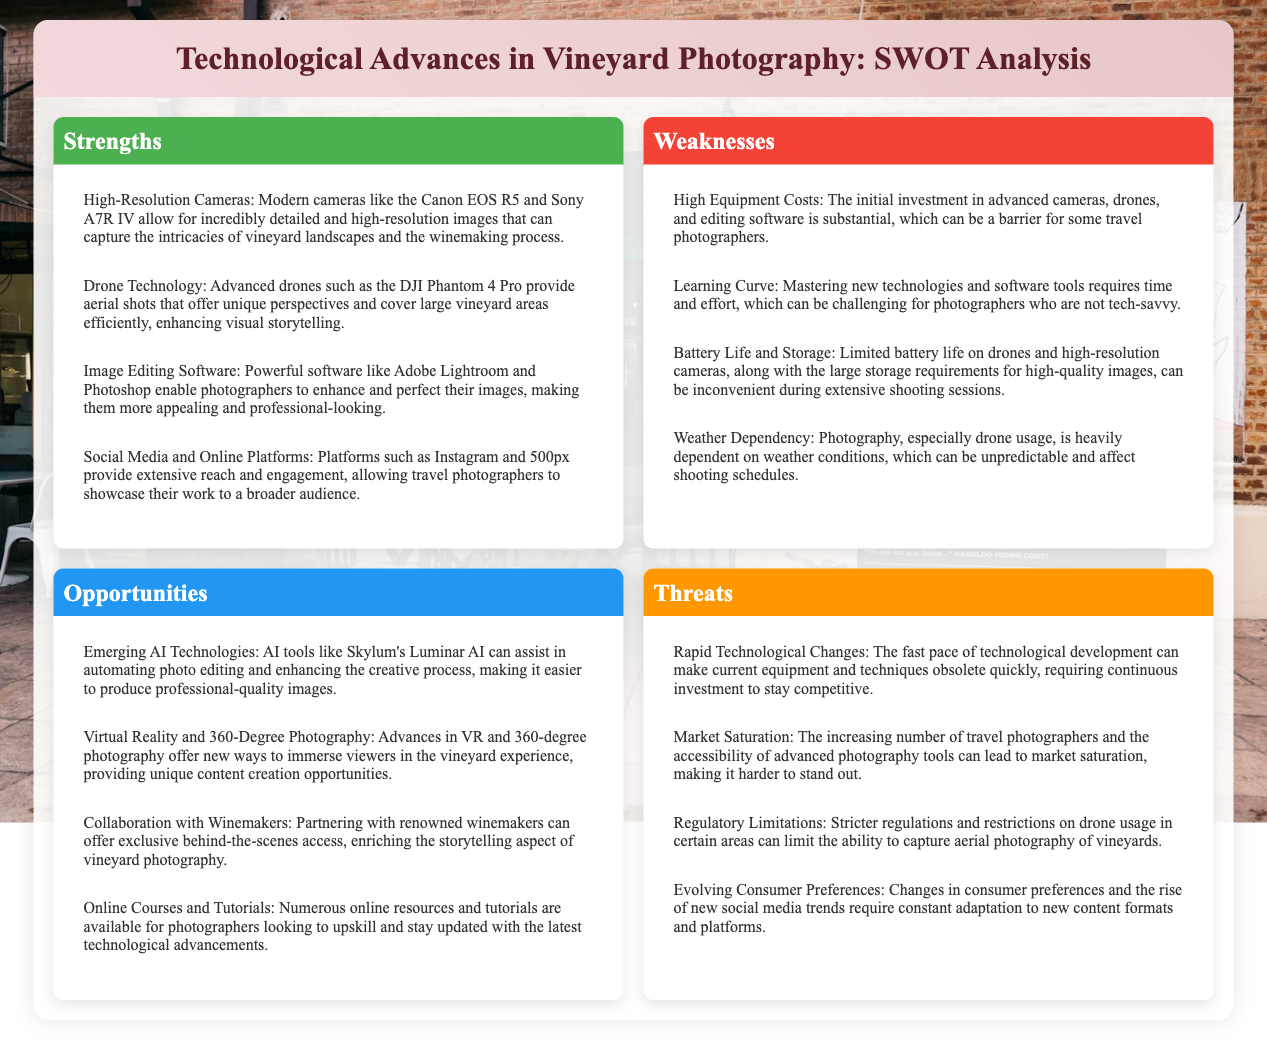What are two examples of high-resolution cameras? The document lists two examples of high-resolution cameras: Canon EOS R5 and Sony A7R IV.
Answer: Canon EOS R5 and Sony A7R IV What is the main challenge regarding drone usage in vineyard photography? The document states that weather dependency is a significant challenge affecting shooting schedules when using drones.
Answer: Weather dependency Which software is mentioned for enhancing photography images? Adobe Lightroom and Photoshop are mentioned as software tools for enhancing and perfecting images.
Answer: Adobe Lightroom and Photoshop What is one opportunity related to emerging technologies? The document mentions AI tools like Skylum's Luminar AI that can assist in automating photo editing.
Answer: AI tools like Skylum's Luminar AI What is a threat concerning market conditions? The document notes that market saturation is a threat due to the increasing number of travel photographers.
Answer: Market saturation How many strengths are listed in the SWOT analysis? There are four strengths listed in the strengths section of the SWOT analysis.
Answer: Four What can be a barrier for some photographers according to the weaknesses section? High equipment costs are identified as a barrier for some travel photographers in the document.
Answer: High equipment costs What unique feature does drone technology provide for vineyard photography? The document states that drones offer aerial shots that provide unique perspectives of vineyard landscapes.
Answer: Aerial shots What does the document suggest about collaboration with winemakers? It suggests that collaboration with winemakers can provide exclusive behind-the-scenes access.
Answer: Exclusive behind-the-scenes access 